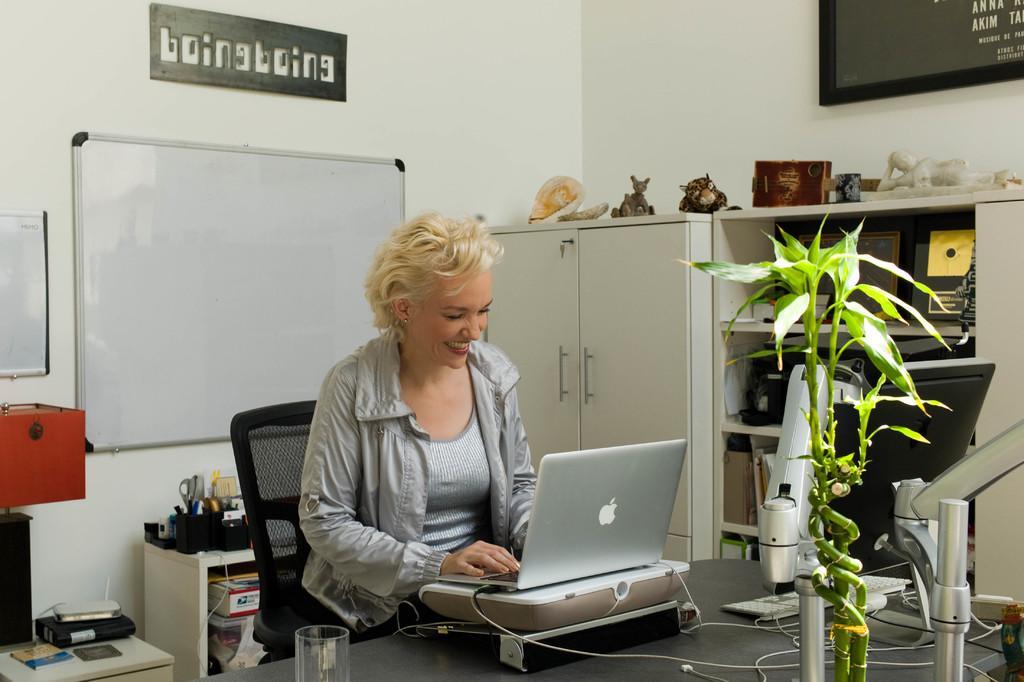Describe this image in one or two sentences. In this image we can see a woman wearing jacket is sitting on the chair and using the laptop which is in front of her. Here we can see glass, a plant, monitor and keyboard on the table. Here we can see the stand. In the background, we can see board, table on which some things are kept, cupboards, shelves, name board and photo frame on the wall. 